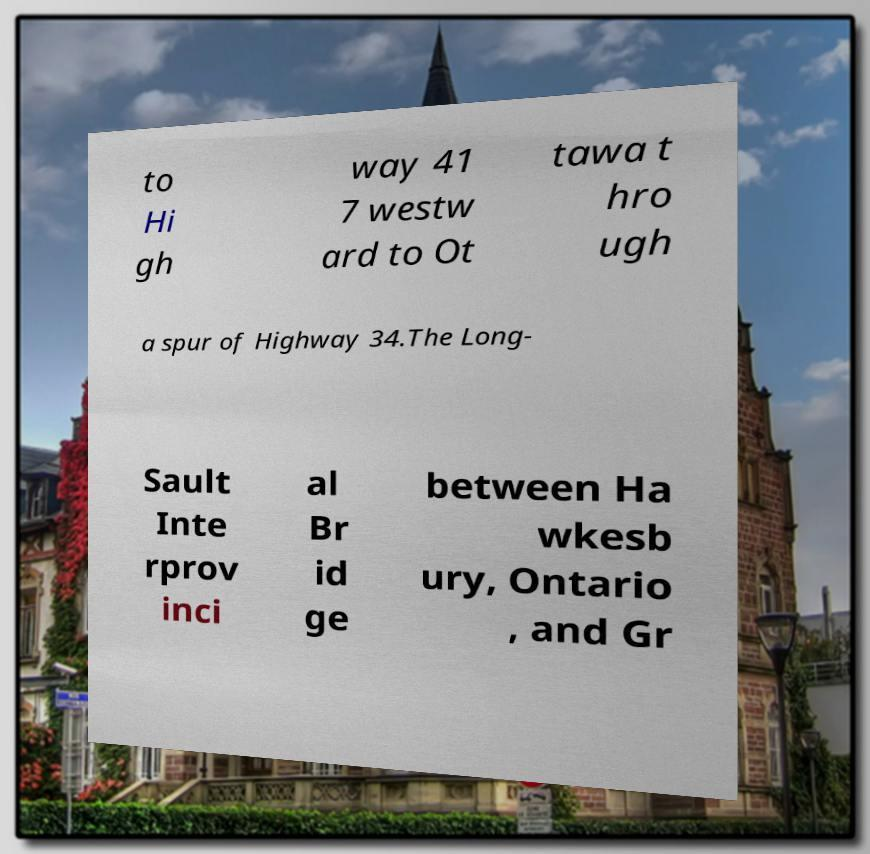Can you accurately transcribe the text from the provided image for me? to Hi gh way 41 7 westw ard to Ot tawa t hro ugh a spur of Highway 34.The Long- Sault Inte rprov inci al Br id ge between Ha wkesb ury, Ontario , and Gr 